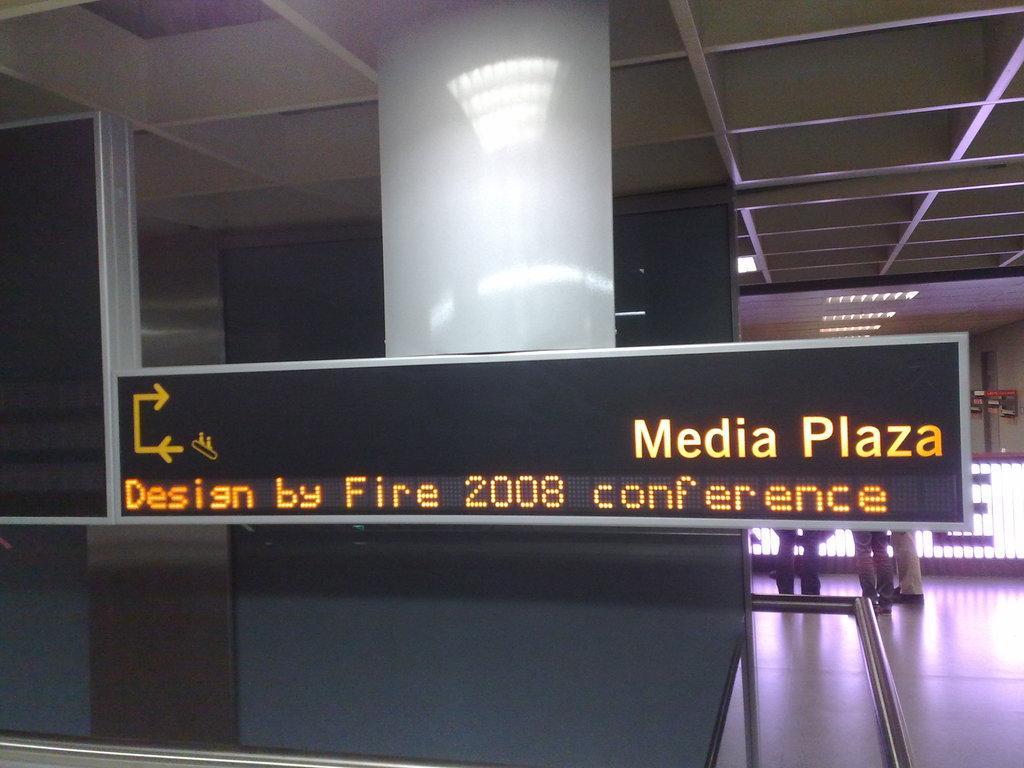Can you describe this image briefly? This image is taken indoors. At the top of the image there is a roof. There are a few lights. On the right side of the image there is a floor. There is a window blind with a text on it. In the background there is a wall and a few people are standing on the floor. In the middle of the image there is a pillar and there is a digital board with a text on it. 